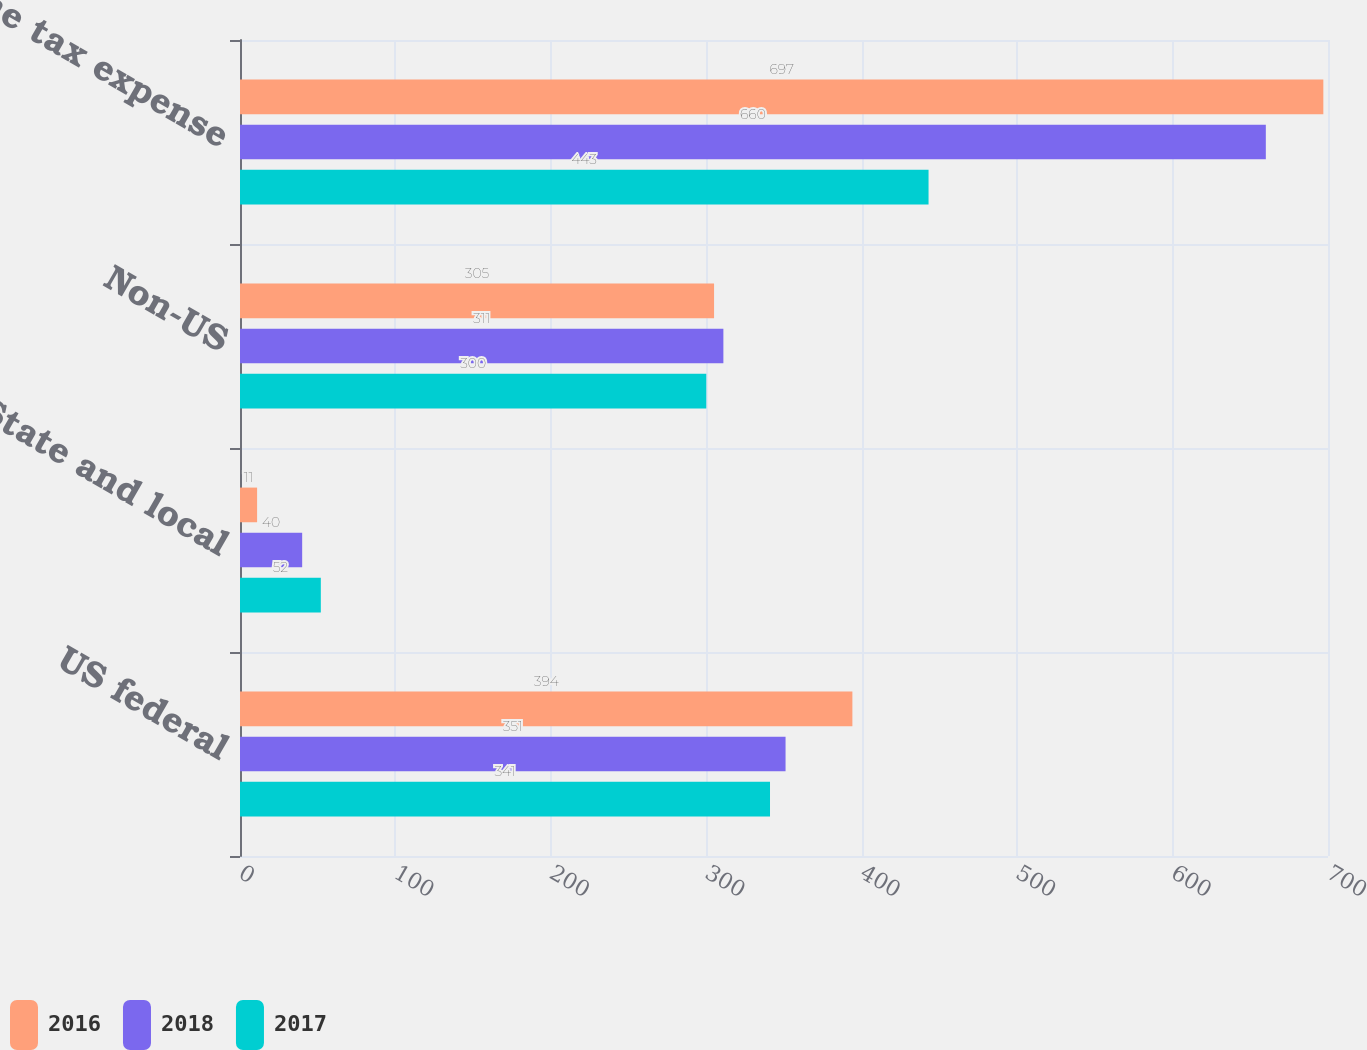Convert chart. <chart><loc_0><loc_0><loc_500><loc_500><stacked_bar_chart><ecel><fcel>US federal<fcel>State and local<fcel>Non-US<fcel>Income tax expense<nl><fcel>2016<fcel>394<fcel>11<fcel>305<fcel>697<nl><fcel>2018<fcel>351<fcel>40<fcel>311<fcel>660<nl><fcel>2017<fcel>341<fcel>52<fcel>300<fcel>443<nl></chart> 